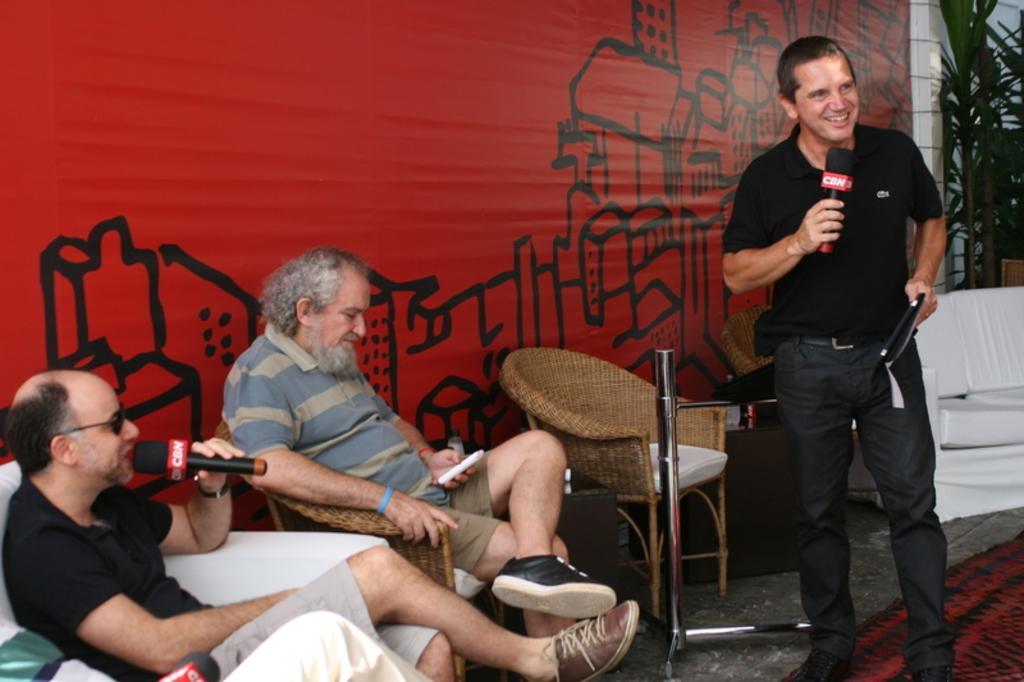Could you give a brief overview of what you see in this image? In the image we can see there are people sitting on the chairs and a man is holding mic in his hand. There is another man holding mobile phone is his hand and there is a man standing in front of them and holding mic in his hand. Behind there are plants and there is banner on the wall. 